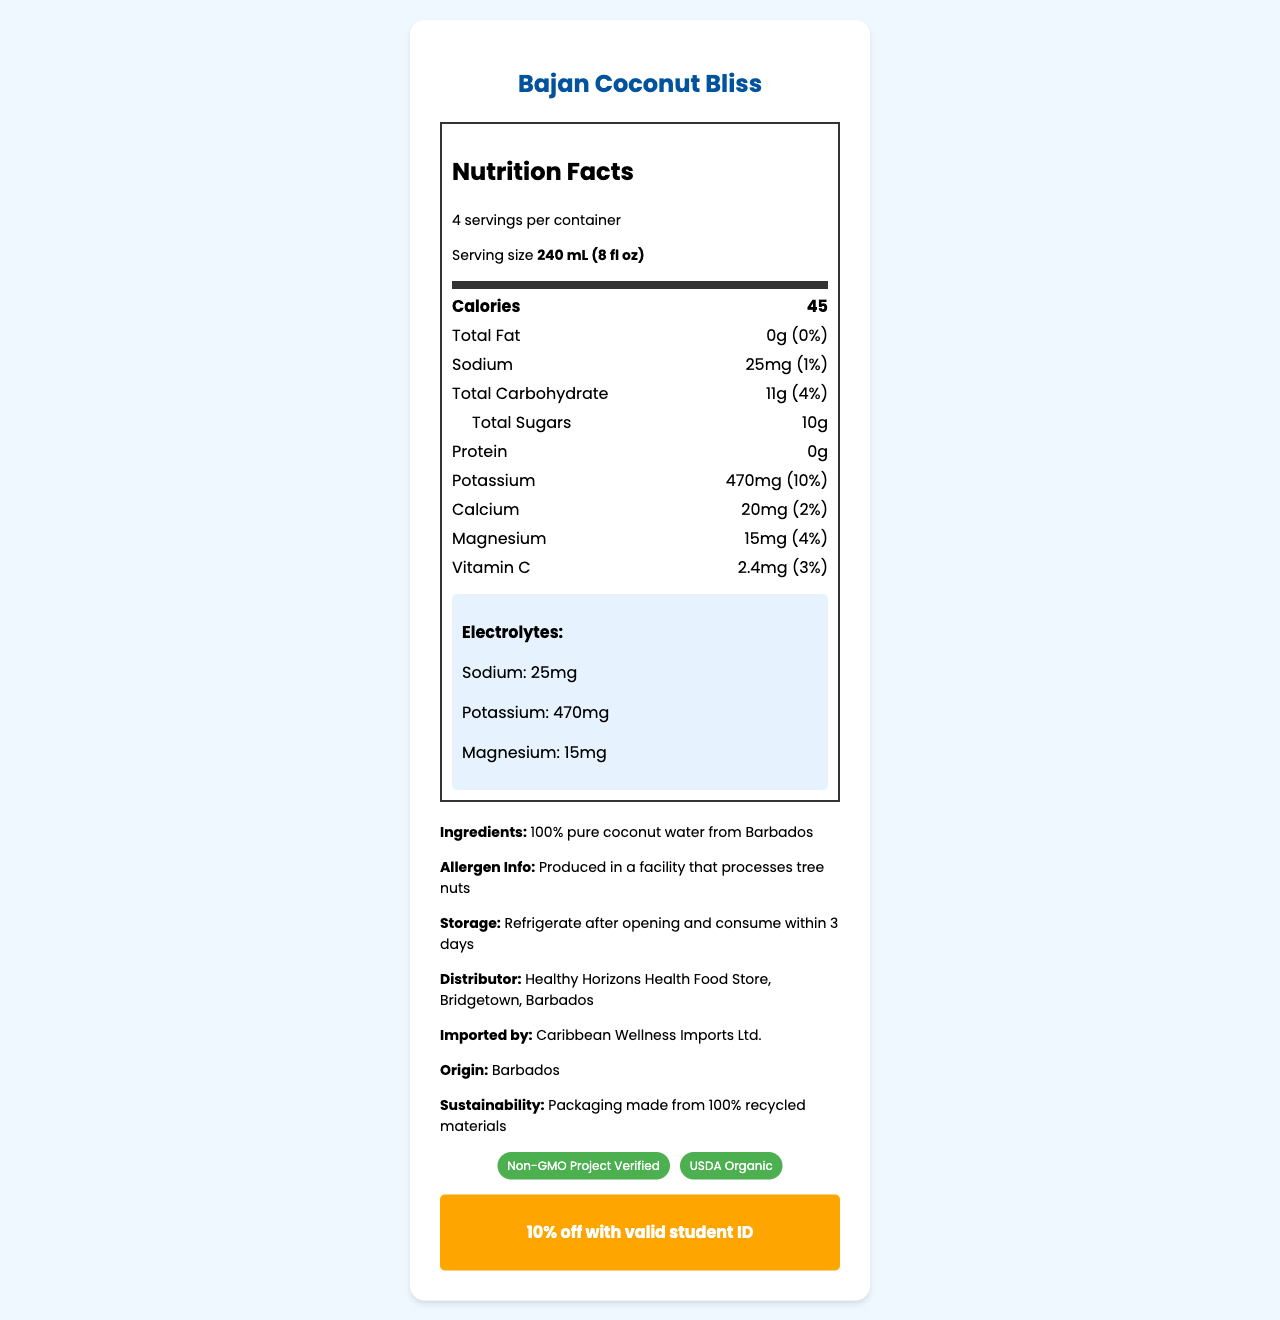what is the serving size? The serving size is stated in the document as 240 mL (8 fl oz).
Answer: 240 mL (8 fl oz) how many calories are in one serving? The calorie count is listed in the document as 45 calories per serving.
Answer: 45 what is the amount of sodium per serving? The sodium content per serving is explicitly specified as 25mg.
Answer: 25mg what is the total carbohydrate content per serving? The total carbohydrate amount per serving is given as 11g.
Answer: 11g how much potassium does one serving contain? The potassium content per serving is indicated as 470mg.
Answer: 470mg what are the ingredients of Bajan Coconut Bliss? The document lists the ingredients as 100% pure coconut water from Barbados.
Answer: 100% pure coconut water from Barbados where is the Bajan Coconut Bliss imported from? A. Jamaica B. Trinidad C. Barbados D. St. Lucia The document states that the origin of the product is Barbados.
Answer: C. Barbados how much discount can students get with a valid student ID? A. 5% B. 10% C. 15% D. 20% The student discount provided is 10% off with a valid student ID.
Answer: B. 10% is the product USDA Organic certified? The document shows that the product has a USDA Organic certification.
Answer: Yes is this product suitable for someone with a tree nut allergy? The allergen information notes that the product is produced in a facility that processes tree nuts.
Answer: No summarize the main nutritional benefits of Bajan Coconut Bliss. The document highlights the product’s electrolyte content (sodium, potassium, magnesium), its low-calorie count, zero fat and protein, and its certifications including USDA Organic and Non-GMO Verified.
Answer: Bajan Coconut Bliss provides hydration with electrolytes like sodium, potassium, and magnesium, with low calorie and no fat content. It is also USDA Organic and Non-GMO certified. how long should the product be consumed after opening? The storage instructions clearly state the product should be consumed within 3 days after opening.
Answer: Within 3 days how much protein does one serving of Bajan Coconut Bliss contain? The document specifies that there is 0g of protein per serving.
Answer: 0g what is the magnesium content in one serving, and how does it contribute to the daily value? The magnesium content is listed as 15mg which contributes 4% to the daily value.
Answer: 15mg, 4% can you determine the price of Bajan Coconut Bliss from the document? The document does not provide any information regarding the price of the product.
Answer: Not enough information 